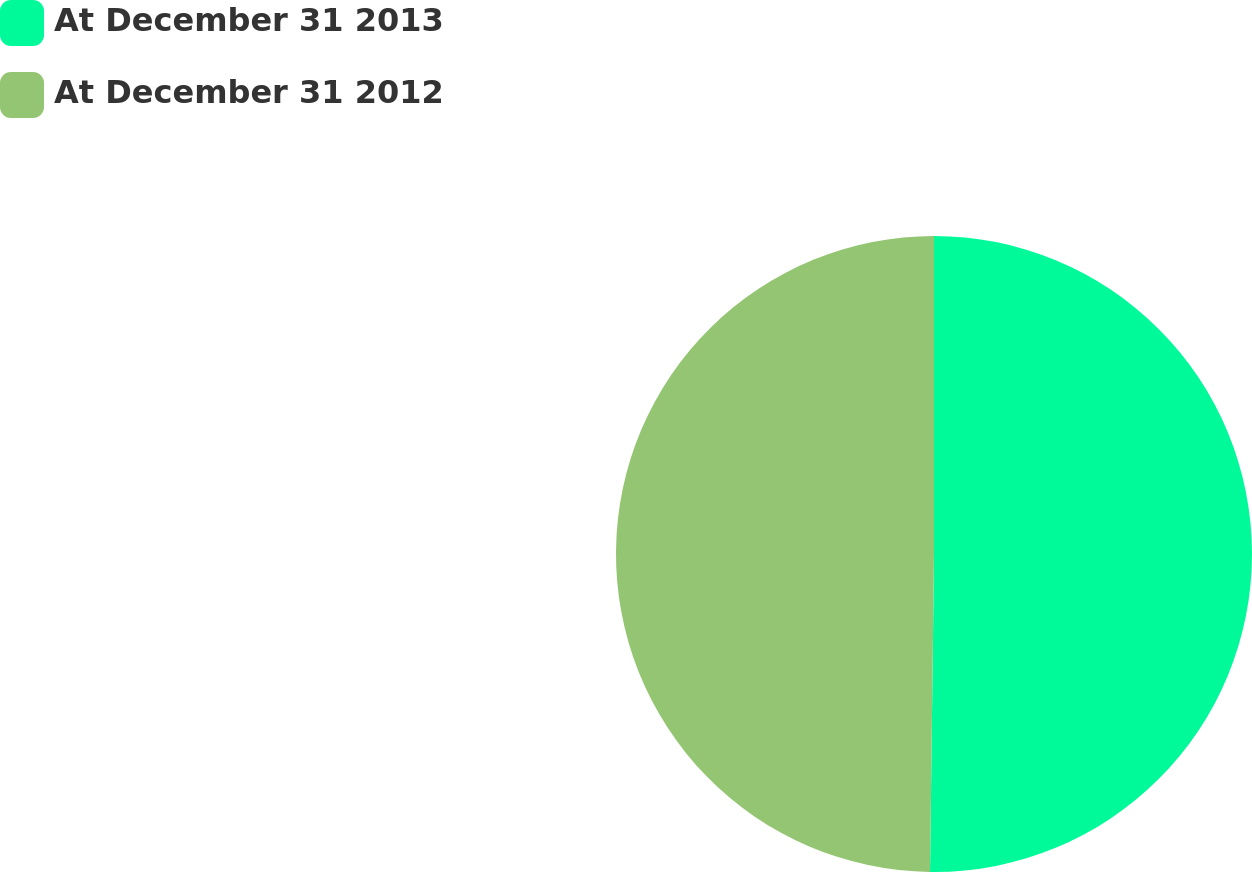Convert chart. <chart><loc_0><loc_0><loc_500><loc_500><pie_chart><fcel>At December 31 2013<fcel>At December 31 2012<nl><fcel>50.2%<fcel>49.8%<nl></chart> 